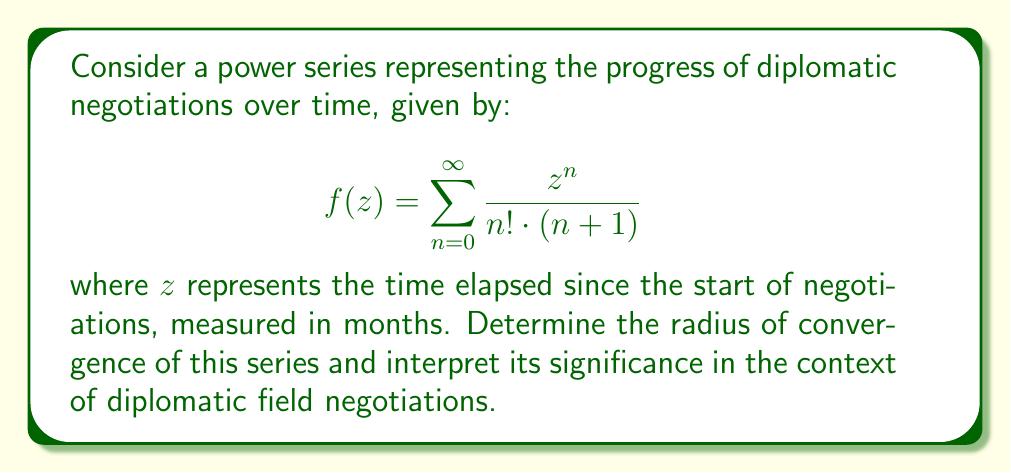Could you help me with this problem? To analyze the convergence of this power series, we'll use the ratio test:

1) First, let's define the general term of the series:

   $$a_n = \frac{1}{n! \cdot (n+1)}$$

2) Apply the ratio test:

   $$\lim_{n \to \infty} \left|\frac{a_{n+1}}{a_n}\right| = \lim_{n \to \infty} \left|\frac{\frac{1}{(n+1)! \cdot (n+2)}}{\frac{1}{n! \cdot (n+1)}}\right|$$

3) Simplify:

   $$\lim_{n \to \infty} \left|\frac{n! \cdot (n+1)}{(n+1)! \cdot (n+2)}\right| = \lim_{n \to \infty} \left|\frac{1}{n+2}\right|$$

4) Evaluate the limit:

   $$\lim_{n \to \infty} \frac{1}{n+2} = 0$$

5) The radius of convergence $R$ is given by:

   $$R = \frac{1}{\lim_{n \to \infty} \left|\frac{a_{n+1}}{a_n}\right|} = \frac{1}{0} = \infty$$

Interpretation: The radius of convergence being infinite means that the series converges for all complex values of $z$. In the context of diplomatic field negotiations, this suggests that the model predicts the negotiations can theoretically continue indefinitely without breaking down, regardless of how much time passes. This aligns with the persona's belief in conducting diplomacy "in the fields," as it implies a patient, long-term approach to negotiations that can adapt to various time scales and continue making progress, no matter how slowly.
Answer: The radius of convergence is $R = \infty$, meaning the series converges for all complex values of $z$. 